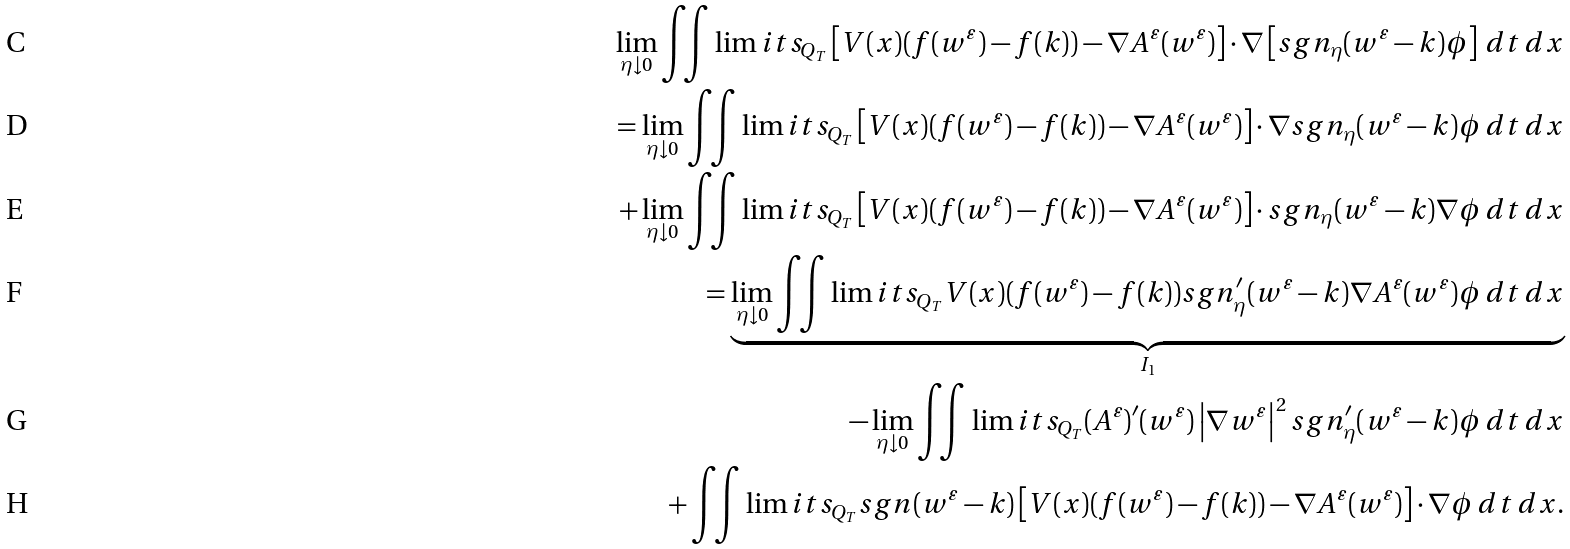<formula> <loc_0><loc_0><loc_500><loc_500>\lim _ { \eta \downarrow 0 } \iint \lim i t s _ { Q _ { T } } \left [ V ( x ) ( f ( w ^ { \varepsilon } ) - f ( k ) ) - \nabla A ^ { \varepsilon } ( w ^ { \varepsilon } ) \right ] \cdot \nabla \left [ s g n _ { \eta } ( w ^ { \varepsilon } - k ) \phi \right ] \, d t \, d x \\ = \lim _ { \eta \downarrow 0 } \iint \lim i t s _ { Q _ { T } } \left [ V ( x ) ( f ( w ^ { \varepsilon } ) - f ( k ) ) - \nabla A ^ { \varepsilon } ( w ^ { \varepsilon } ) \right ] \cdot \nabla s g n _ { \eta } ( w ^ { \varepsilon } - k ) \phi \, d t \, d x \\ + \lim _ { \eta \downarrow 0 } \iint \lim i t s _ { Q _ { T } } \left [ V ( x ) ( f ( w ^ { \varepsilon } ) - f ( k ) ) - \nabla A ^ { \varepsilon } ( w ^ { \varepsilon } ) \right ] \cdot s g n _ { \eta } ( w ^ { \varepsilon } - k ) \nabla \phi \, d t \, d x \\ = \underbrace { \lim _ { \eta \downarrow 0 } \iint \lim i t s _ { Q _ { T } } V ( x ) ( f ( w ^ { \varepsilon } ) - f ( k ) ) s g n _ { \eta } ^ { \prime } ( w ^ { \varepsilon } - k ) \nabla A ^ { \varepsilon } ( w ^ { \varepsilon } ) \phi \, d t \, d x } _ { I _ { 1 } } \\ - \lim _ { \eta \downarrow 0 } \iint \lim i t s _ { Q _ { T } } ( A ^ { \varepsilon } ) ^ { \prime } ( w ^ { \varepsilon } ) \left | \nabla w ^ { \varepsilon } \right | ^ { 2 } s g n _ { \eta } ^ { \prime } ( w ^ { \varepsilon } - k ) \phi \, d t \, d x \\ + \iint \lim i t s _ { Q _ { T } } s g n ( w ^ { \varepsilon } - k ) \left [ V ( x ) ( f ( w ^ { \varepsilon } ) - f ( k ) ) - \nabla A ^ { \varepsilon } ( w ^ { \varepsilon } ) \right ] \cdot \nabla \phi \, d t \, d x .</formula> 